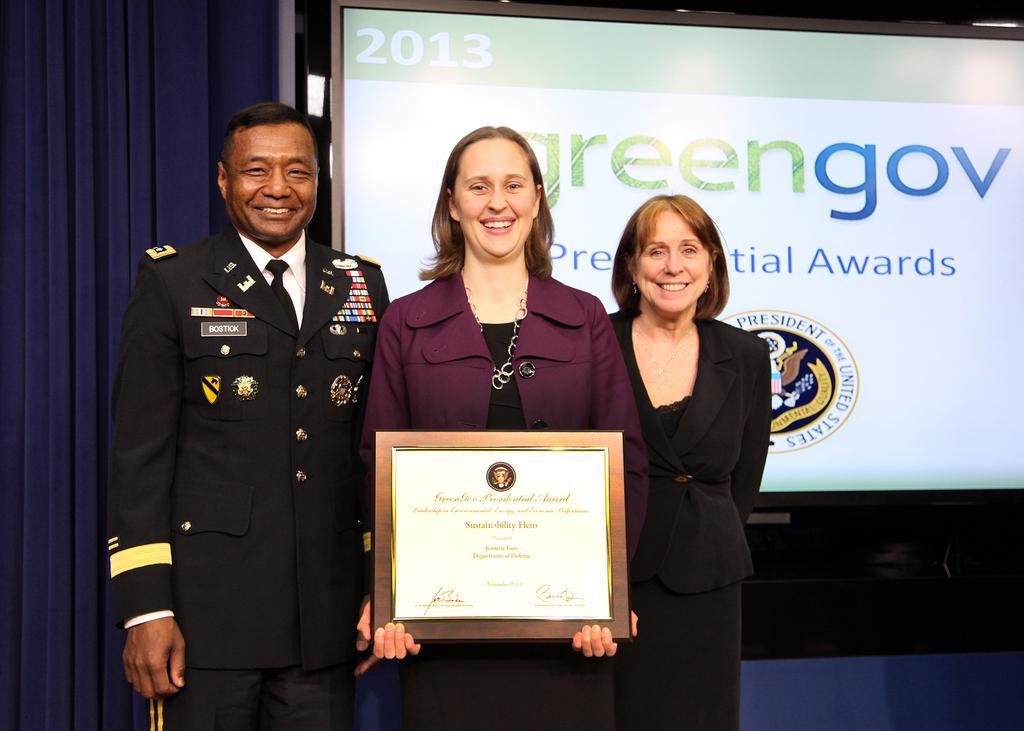Please provide a concise description of this image. In this picture I can see three persons standing and smiling, a person holding a certificate , and in the background there is a screen. 